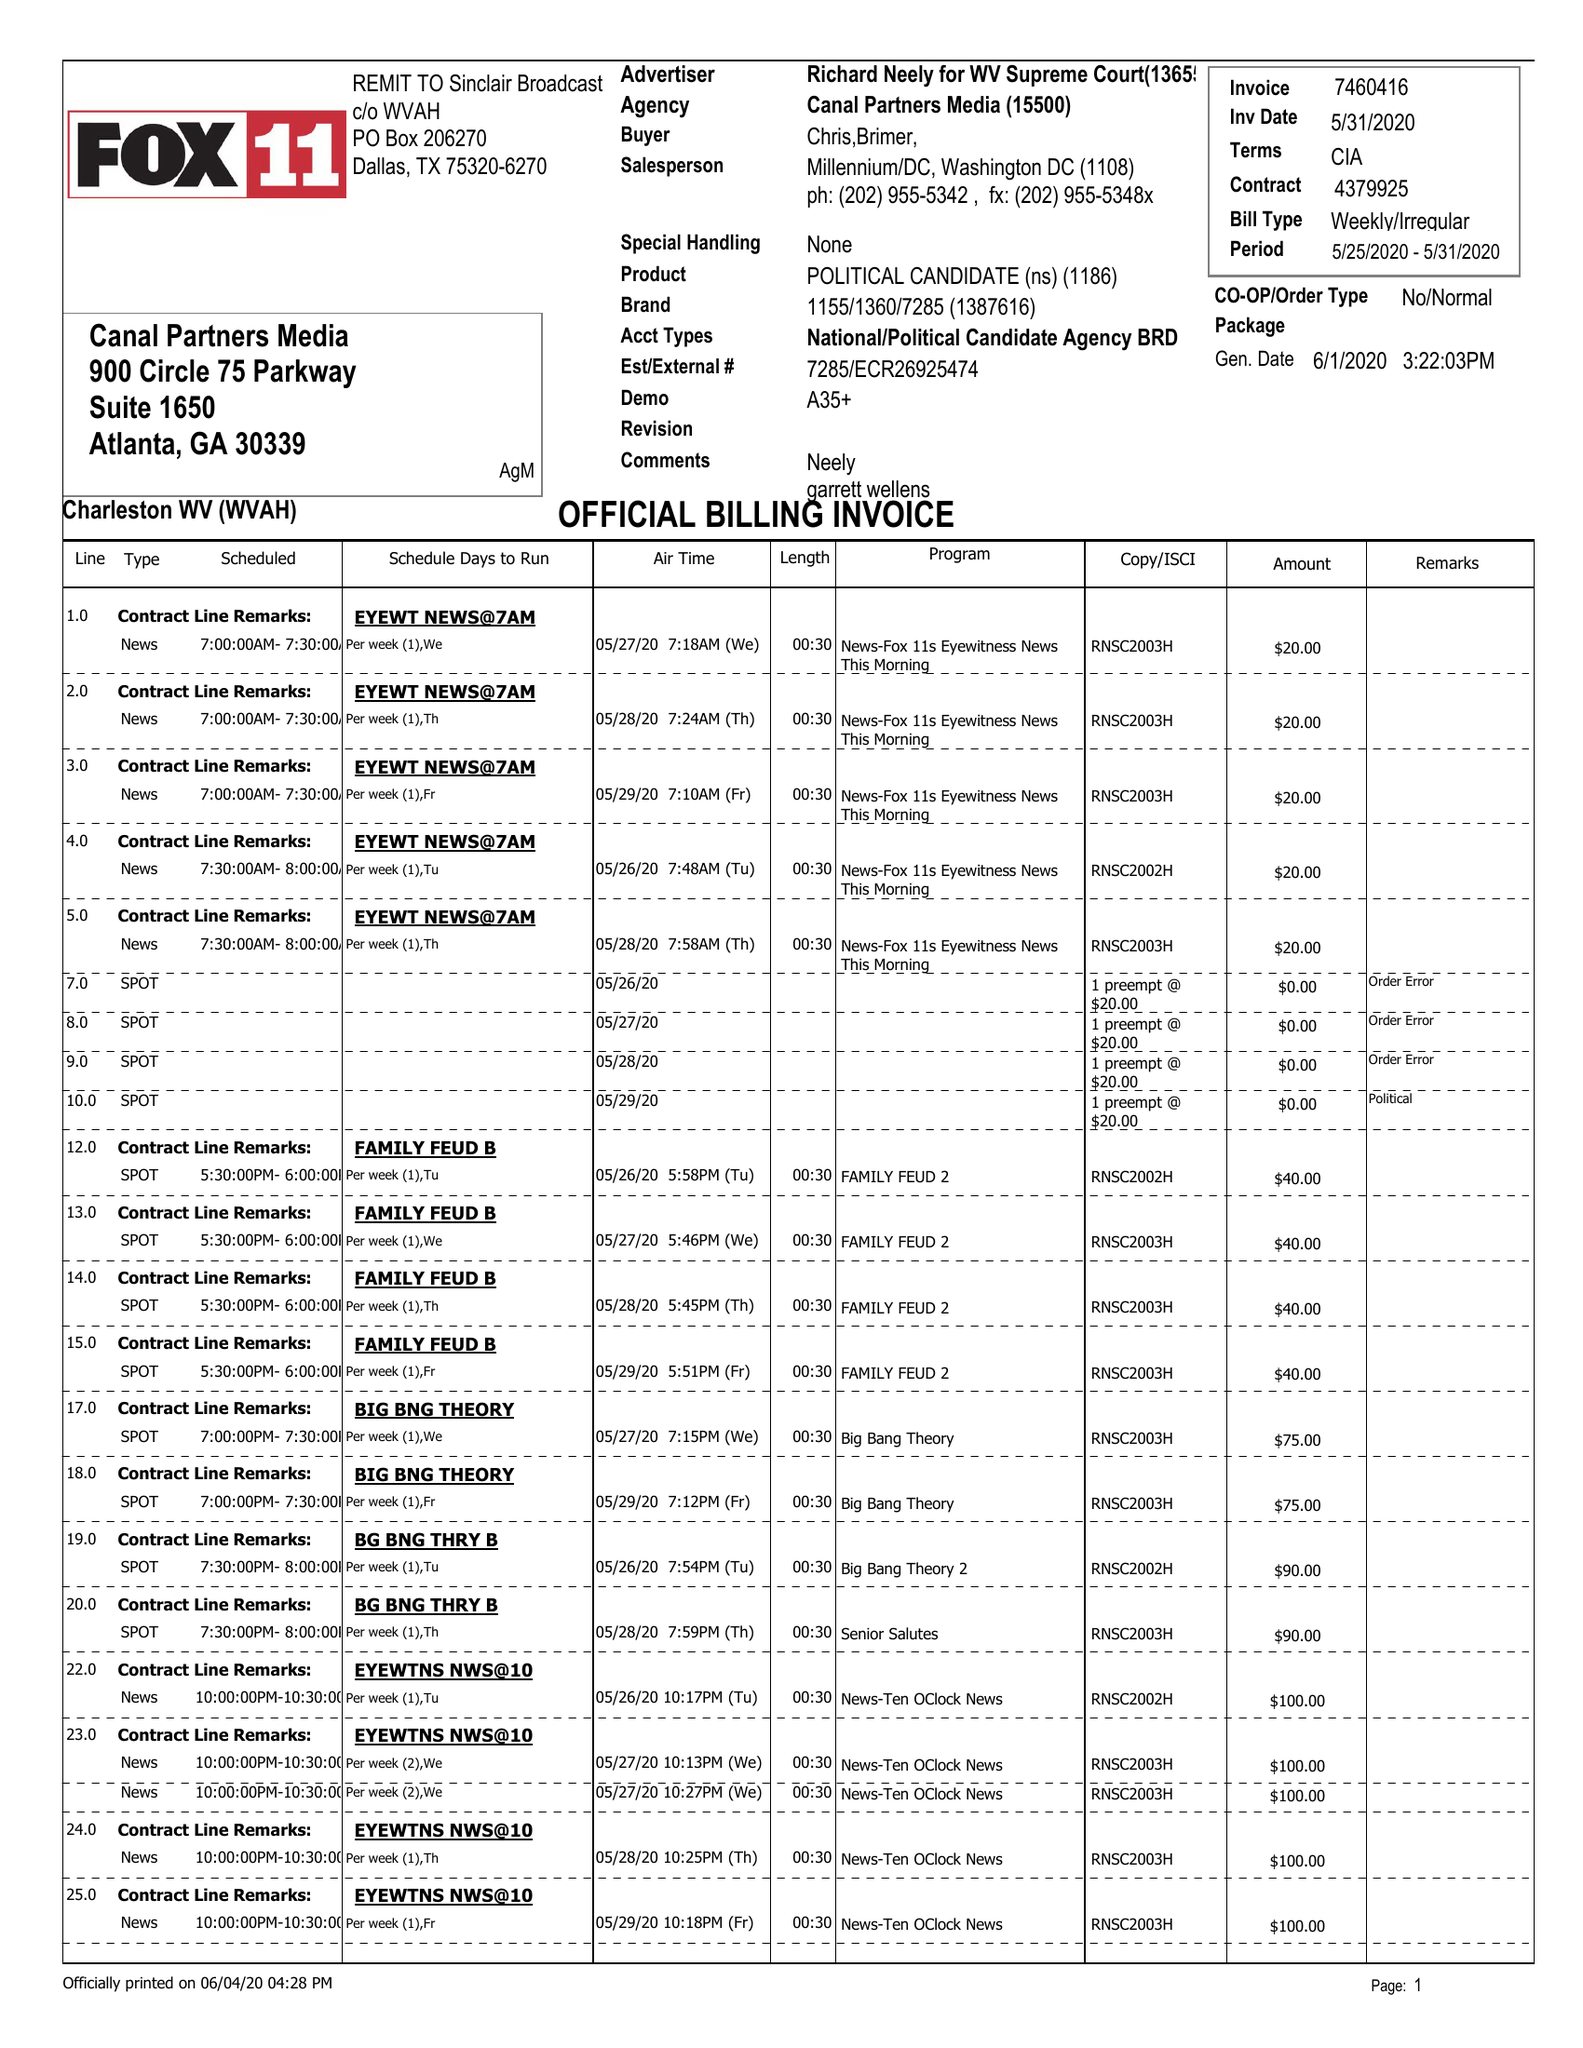What is the value for the contract_num?
Answer the question using a single word or phrase. 4379925 